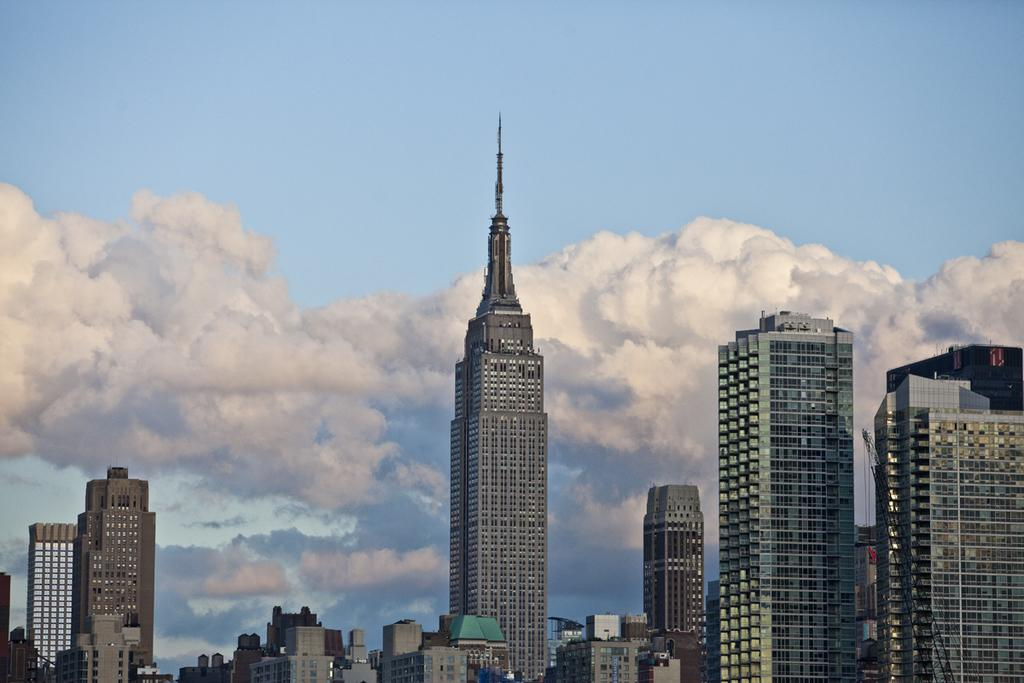What is the main structure in the center of the image? There is a tower in the center of the image. What other structures can be seen at the bottom of the image? There are buildings at the bottom of the image. What can be observed in the sky in the background of the image? There are clouds visible in the sky in the background of the image. Can you see a goat climbing the tower in the image? There is no goat present in the image, and therefore no goat can be seen climbing the tower. 